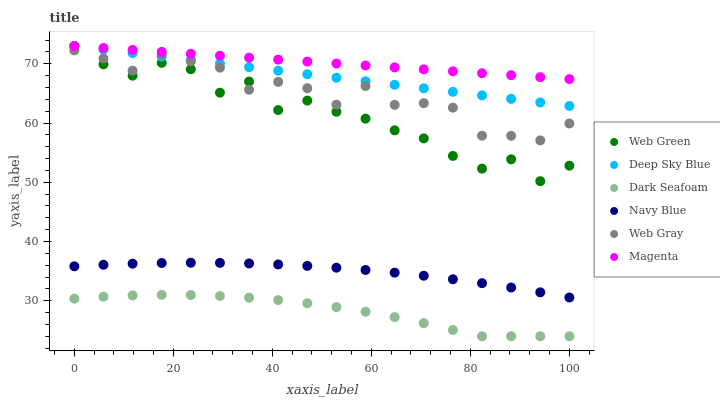Does Dark Seafoam have the minimum area under the curve?
Answer yes or no. Yes. Does Magenta have the maximum area under the curve?
Answer yes or no. Yes. Does Navy Blue have the minimum area under the curve?
Answer yes or no. No. Does Navy Blue have the maximum area under the curve?
Answer yes or no. No. Is Magenta the smoothest?
Answer yes or no. Yes. Is Web Green the roughest?
Answer yes or no. Yes. Is Navy Blue the smoothest?
Answer yes or no. No. Is Navy Blue the roughest?
Answer yes or no. No. Does Dark Seafoam have the lowest value?
Answer yes or no. Yes. Does Navy Blue have the lowest value?
Answer yes or no. No. Does Magenta have the highest value?
Answer yes or no. Yes. Does Navy Blue have the highest value?
Answer yes or no. No. Is Dark Seafoam less than Web Green?
Answer yes or no. Yes. Is Deep Sky Blue greater than Dark Seafoam?
Answer yes or no. Yes. Does Web Green intersect Web Gray?
Answer yes or no. Yes. Is Web Green less than Web Gray?
Answer yes or no. No. Is Web Green greater than Web Gray?
Answer yes or no. No. Does Dark Seafoam intersect Web Green?
Answer yes or no. No. 